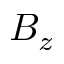Convert formula to latex. <formula><loc_0><loc_0><loc_500><loc_500>B _ { z }</formula> 